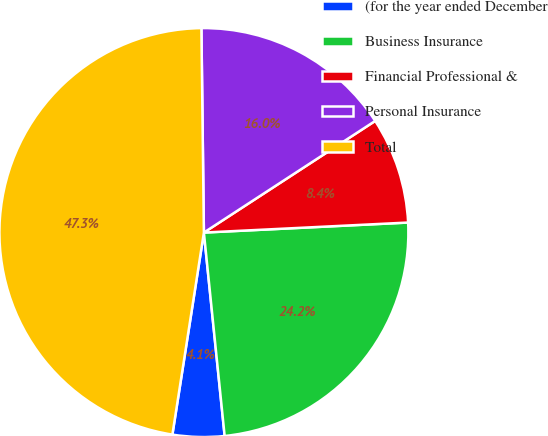Convert chart. <chart><loc_0><loc_0><loc_500><loc_500><pie_chart><fcel>(for the year ended December<fcel>Business Insurance<fcel>Financial Professional &<fcel>Personal Insurance<fcel>Total<nl><fcel>4.08%<fcel>24.16%<fcel>8.41%<fcel>16.0%<fcel>47.34%<nl></chart> 